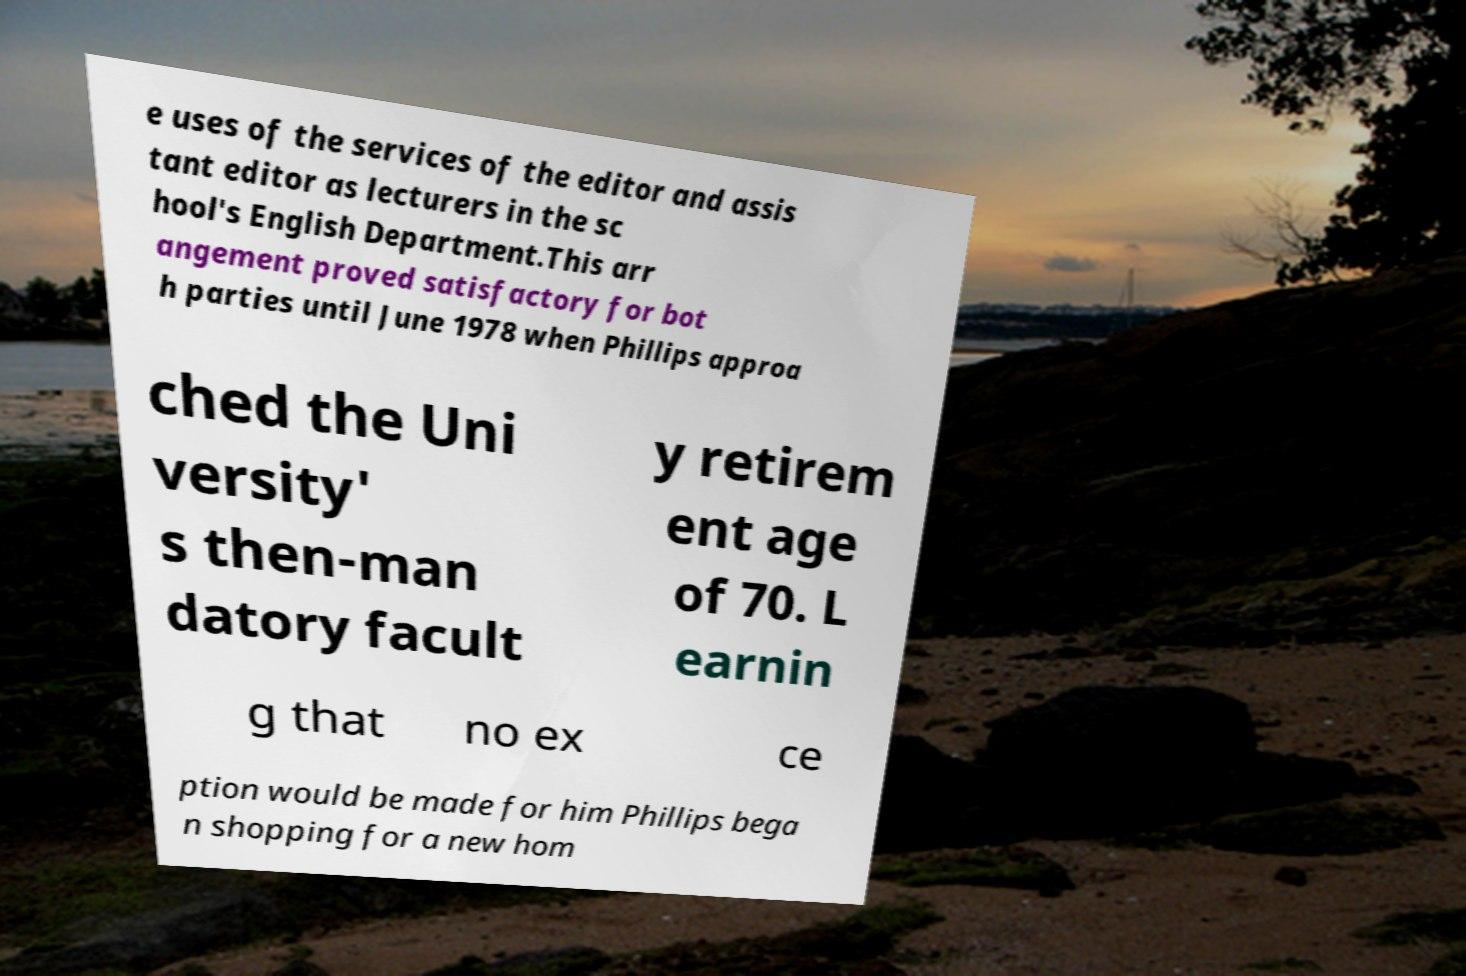Could you extract and type out the text from this image? e uses of the services of the editor and assis tant editor as lecturers in the sc hool's English Department.This arr angement proved satisfactory for bot h parties until June 1978 when Phillips approa ched the Uni versity' s then-man datory facult y retirem ent age of 70. L earnin g that no ex ce ption would be made for him Phillips bega n shopping for a new hom 